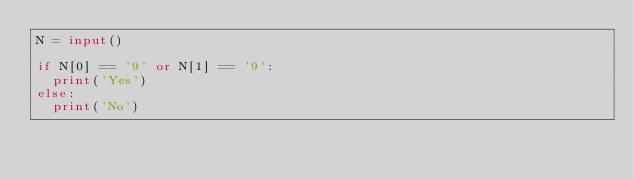<code> <loc_0><loc_0><loc_500><loc_500><_Python_>N = input()

if N[0] == '9' or N[1] == '9':
	print('Yes')
else:
	print('No')</code> 